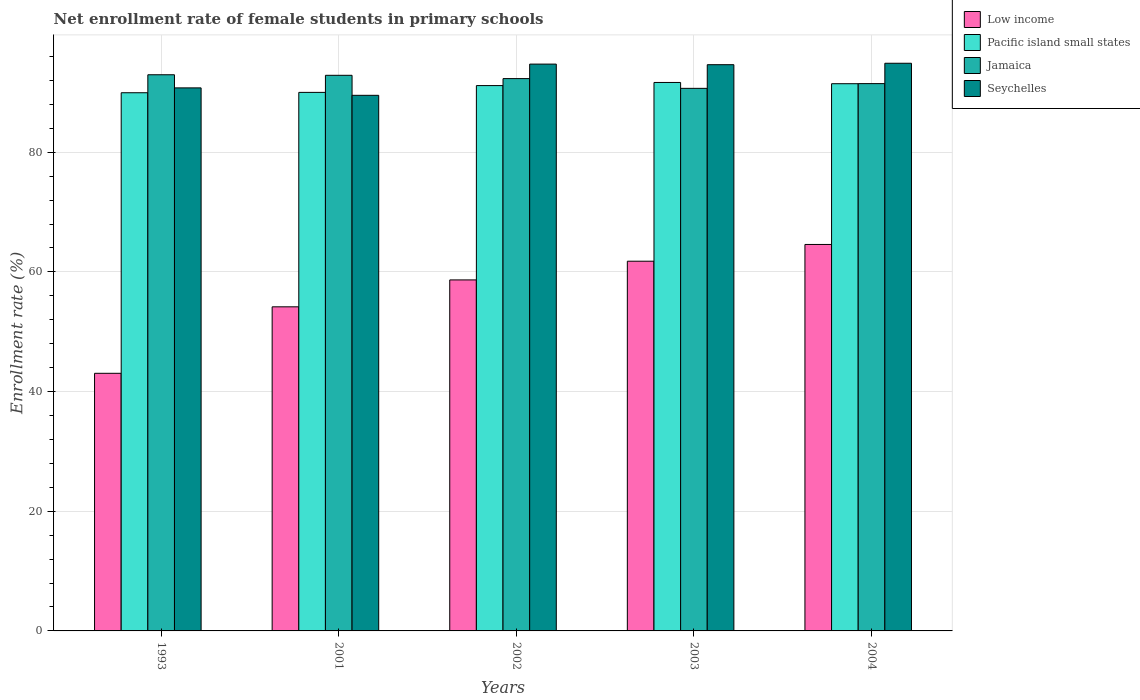How many different coloured bars are there?
Give a very brief answer. 4. How many groups of bars are there?
Your answer should be very brief. 5. Are the number of bars per tick equal to the number of legend labels?
Ensure brevity in your answer.  Yes. How many bars are there on the 4th tick from the left?
Make the answer very short. 4. How many bars are there on the 5th tick from the right?
Ensure brevity in your answer.  4. What is the label of the 2nd group of bars from the left?
Make the answer very short. 2001. In how many cases, is the number of bars for a given year not equal to the number of legend labels?
Keep it short and to the point. 0. What is the net enrollment rate of female students in primary schools in Jamaica in 1993?
Keep it short and to the point. 92.94. Across all years, what is the maximum net enrollment rate of female students in primary schools in Seychelles?
Ensure brevity in your answer.  94.86. Across all years, what is the minimum net enrollment rate of female students in primary schools in Pacific island small states?
Keep it short and to the point. 89.94. In which year was the net enrollment rate of female students in primary schools in Seychelles maximum?
Ensure brevity in your answer.  2004. What is the total net enrollment rate of female students in primary schools in Low income in the graph?
Keep it short and to the point. 282.24. What is the difference between the net enrollment rate of female students in primary schools in Pacific island small states in 1993 and that in 2002?
Provide a succinct answer. -1.2. What is the difference between the net enrollment rate of female students in primary schools in Seychelles in 2003 and the net enrollment rate of female students in primary schools in Jamaica in 2004?
Offer a very short reply. 3.16. What is the average net enrollment rate of female students in primary schools in Low income per year?
Give a very brief answer. 56.45. In the year 2002, what is the difference between the net enrollment rate of female students in primary schools in Low income and net enrollment rate of female students in primary schools in Jamaica?
Make the answer very short. -33.64. In how many years, is the net enrollment rate of female students in primary schools in Seychelles greater than 56 %?
Provide a short and direct response. 5. What is the ratio of the net enrollment rate of female students in primary schools in Pacific island small states in 2002 to that in 2004?
Offer a very short reply. 1. Is the net enrollment rate of female students in primary schools in Jamaica in 2001 less than that in 2004?
Make the answer very short. No. What is the difference between the highest and the second highest net enrollment rate of female students in primary schools in Pacific island small states?
Make the answer very short. 0.21. What is the difference between the highest and the lowest net enrollment rate of female students in primary schools in Jamaica?
Keep it short and to the point. 2.27. Is the sum of the net enrollment rate of female students in primary schools in Jamaica in 1993 and 2002 greater than the maximum net enrollment rate of female students in primary schools in Low income across all years?
Your answer should be very brief. Yes. What does the 4th bar from the left in 1993 represents?
Your response must be concise. Seychelles. What does the 2nd bar from the right in 1993 represents?
Your response must be concise. Jamaica. How many bars are there?
Provide a succinct answer. 20. Are all the bars in the graph horizontal?
Offer a terse response. No. Are the values on the major ticks of Y-axis written in scientific E-notation?
Your answer should be very brief. No. Does the graph contain any zero values?
Offer a terse response. No. How many legend labels are there?
Your answer should be very brief. 4. What is the title of the graph?
Provide a succinct answer. Net enrollment rate of female students in primary schools. Does "Aruba" appear as one of the legend labels in the graph?
Give a very brief answer. No. What is the label or title of the Y-axis?
Ensure brevity in your answer.  Enrollment rate (%). What is the Enrollment rate (%) of Low income in 1993?
Give a very brief answer. 43.05. What is the Enrollment rate (%) in Pacific island small states in 1993?
Ensure brevity in your answer.  89.94. What is the Enrollment rate (%) in Jamaica in 1993?
Provide a short and direct response. 92.94. What is the Enrollment rate (%) of Seychelles in 1993?
Keep it short and to the point. 90.75. What is the Enrollment rate (%) of Low income in 2001?
Keep it short and to the point. 54.16. What is the Enrollment rate (%) in Pacific island small states in 2001?
Provide a short and direct response. 90. What is the Enrollment rate (%) of Jamaica in 2001?
Offer a terse response. 92.85. What is the Enrollment rate (%) in Seychelles in 2001?
Make the answer very short. 89.51. What is the Enrollment rate (%) of Low income in 2002?
Keep it short and to the point. 58.66. What is the Enrollment rate (%) in Pacific island small states in 2002?
Make the answer very short. 91.13. What is the Enrollment rate (%) in Jamaica in 2002?
Give a very brief answer. 92.3. What is the Enrollment rate (%) of Seychelles in 2002?
Your response must be concise. 94.72. What is the Enrollment rate (%) of Low income in 2003?
Give a very brief answer. 61.78. What is the Enrollment rate (%) in Pacific island small states in 2003?
Offer a terse response. 91.65. What is the Enrollment rate (%) of Jamaica in 2003?
Make the answer very short. 90.67. What is the Enrollment rate (%) in Seychelles in 2003?
Your answer should be compact. 94.62. What is the Enrollment rate (%) in Low income in 2004?
Provide a succinct answer. 64.58. What is the Enrollment rate (%) in Pacific island small states in 2004?
Make the answer very short. 91.45. What is the Enrollment rate (%) in Jamaica in 2004?
Provide a short and direct response. 91.46. What is the Enrollment rate (%) of Seychelles in 2004?
Provide a succinct answer. 94.86. Across all years, what is the maximum Enrollment rate (%) in Low income?
Offer a very short reply. 64.58. Across all years, what is the maximum Enrollment rate (%) of Pacific island small states?
Provide a short and direct response. 91.65. Across all years, what is the maximum Enrollment rate (%) in Jamaica?
Give a very brief answer. 92.94. Across all years, what is the maximum Enrollment rate (%) in Seychelles?
Provide a short and direct response. 94.86. Across all years, what is the minimum Enrollment rate (%) of Low income?
Make the answer very short. 43.05. Across all years, what is the minimum Enrollment rate (%) in Pacific island small states?
Keep it short and to the point. 89.94. Across all years, what is the minimum Enrollment rate (%) of Jamaica?
Your answer should be very brief. 90.67. Across all years, what is the minimum Enrollment rate (%) in Seychelles?
Provide a short and direct response. 89.51. What is the total Enrollment rate (%) in Low income in the graph?
Provide a succinct answer. 282.24. What is the total Enrollment rate (%) of Pacific island small states in the graph?
Make the answer very short. 454.17. What is the total Enrollment rate (%) in Jamaica in the graph?
Make the answer very short. 460.23. What is the total Enrollment rate (%) of Seychelles in the graph?
Make the answer very short. 464.47. What is the difference between the Enrollment rate (%) of Low income in 1993 and that in 2001?
Keep it short and to the point. -11.11. What is the difference between the Enrollment rate (%) in Pacific island small states in 1993 and that in 2001?
Your response must be concise. -0.06. What is the difference between the Enrollment rate (%) in Jamaica in 1993 and that in 2001?
Ensure brevity in your answer.  0.09. What is the difference between the Enrollment rate (%) of Seychelles in 1993 and that in 2001?
Keep it short and to the point. 1.24. What is the difference between the Enrollment rate (%) of Low income in 1993 and that in 2002?
Give a very brief answer. -15.61. What is the difference between the Enrollment rate (%) of Pacific island small states in 1993 and that in 2002?
Your response must be concise. -1.2. What is the difference between the Enrollment rate (%) of Jamaica in 1993 and that in 2002?
Offer a terse response. 0.64. What is the difference between the Enrollment rate (%) of Seychelles in 1993 and that in 2002?
Your answer should be compact. -3.97. What is the difference between the Enrollment rate (%) of Low income in 1993 and that in 2003?
Ensure brevity in your answer.  -18.73. What is the difference between the Enrollment rate (%) in Pacific island small states in 1993 and that in 2003?
Provide a short and direct response. -1.72. What is the difference between the Enrollment rate (%) of Jamaica in 1993 and that in 2003?
Provide a short and direct response. 2.27. What is the difference between the Enrollment rate (%) in Seychelles in 1993 and that in 2003?
Your answer should be compact. -3.88. What is the difference between the Enrollment rate (%) of Low income in 1993 and that in 2004?
Provide a succinct answer. -21.53. What is the difference between the Enrollment rate (%) in Pacific island small states in 1993 and that in 2004?
Your answer should be very brief. -1.51. What is the difference between the Enrollment rate (%) in Jamaica in 1993 and that in 2004?
Provide a succinct answer. 1.48. What is the difference between the Enrollment rate (%) in Seychelles in 1993 and that in 2004?
Ensure brevity in your answer.  -4.12. What is the difference between the Enrollment rate (%) of Low income in 2001 and that in 2002?
Make the answer very short. -4.5. What is the difference between the Enrollment rate (%) in Pacific island small states in 2001 and that in 2002?
Keep it short and to the point. -1.14. What is the difference between the Enrollment rate (%) in Jamaica in 2001 and that in 2002?
Your answer should be very brief. 0.55. What is the difference between the Enrollment rate (%) of Seychelles in 2001 and that in 2002?
Offer a very short reply. -5.22. What is the difference between the Enrollment rate (%) in Low income in 2001 and that in 2003?
Provide a succinct answer. -7.62. What is the difference between the Enrollment rate (%) in Pacific island small states in 2001 and that in 2003?
Your answer should be very brief. -1.66. What is the difference between the Enrollment rate (%) of Jamaica in 2001 and that in 2003?
Your answer should be very brief. 2.18. What is the difference between the Enrollment rate (%) in Seychelles in 2001 and that in 2003?
Offer a very short reply. -5.12. What is the difference between the Enrollment rate (%) of Low income in 2001 and that in 2004?
Your answer should be compact. -10.42. What is the difference between the Enrollment rate (%) of Pacific island small states in 2001 and that in 2004?
Your answer should be compact. -1.45. What is the difference between the Enrollment rate (%) of Jamaica in 2001 and that in 2004?
Make the answer very short. 1.39. What is the difference between the Enrollment rate (%) of Seychelles in 2001 and that in 2004?
Provide a succinct answer. -5.36. What is the difference between the Enrollment rate (%) of Low income in 2002 and that in 2003?
Offer a very short reply. -3.12. What is the difference between the Enrollment rate (%) of Pacific island small states in 2002 and that in 2003?
Your answer should be very brief. -0.52. What is the difference between the Enrollment rate (%) of Jamaica in 2002 and that in 2003?
Your response must be concise. 1.63. What is the difference between the Enrollment rate (%) of Seychelles in 2002 and that in 2003?
Provide a short and direct response. 0.1. What is the difference between the Enrollment rate (%) of Low income in 2002 and that in 2004?
Your answer should be compact. -5.93. What is the difference between the Enrollment rate (%) of Pacific island small states in 2002 and that in 2004?
Your answer should be very brief. -0.31. What is the difference between the Enrollment rate (%) in Jamaica in 2002 and that in 2004?
Provide a short and direct response. 0.84. What is the difference between the Enrollment rate (%) in Seychelles in 2002 and that in 2004?
Keep it short and to the point. -0.14. What is the difference between the Enrollment rate (%) of Low income in 2003 and that in 2004?
Provide a short and direct response. -2.8. What is the difference between the Enrollment rate (%) in Pacific island small states in 2003 and that in 2004?
Keep it short and to the point. 0.21. What is the difference between the Enrollment rate (%) of Jamaica in 2003 and that in 2004?
Your answer should be very brief. -0.79. What is the difference between the Enrollment rate (%) in Seychelles in 2003 and that in 2004?
Offer a terse response. -0.24. What is the difference between the Enrollment rate (%) in Low income in 1993 and the Enrollment rate (%) in Pacific island small states in 2001?
Give a very brief answer. -46.95. What is the difference between the Enrollment rate (%) in Low income in 1993 and the Enrollment rate (%) in Jamaica in 2001?
Your answer should be compact. -49.8. What is the difference between the Enrollment rate (%) in Low income in 1993 and the Enrollment rate (%) in Seychelles in 2001?
Give a very brief answer. -46.46. What is the difference between the Enrollment rate (%) of Pacific island small states in 1993 and the Enrollment rate (%) of Jamaica in 2001?
Provide a succinct answer. -2.91. What is the difference between the Enrollment rate (%) of Pacific island small states in 1993 and the Enrollment rate (%) of Seychelles in 2001?
Provide a succinct answer. 0.43. What is the difference between the Enrollment rate (%) of Jamaica in 1993 and the Enrollment rate (%) of Seychelles in 2001?
Offer a very short reply. 3.44. What is the difference between the Enrollment rate (%) in Low income in 1993 and the Enrollment rate (%) in Pacific island small states in 2002?
Ensure brevity in your answer.  -48.08. What is the difference between the Enrollment rate (%) of Low income in 1993 and the Enrollment rate (%) of Jamaica in 2002?
Your response must be concise. -49.25. What is the difference between the Enrollment rate (%) of Low income in 1993 and the Enrollment rate (%) of Seychelles in 2002?
Your answer should be very brief. -51.67. What is the difference between the Enrollment rate (%) of Pacific island small states in 1993 and the Enrollment rate (%) of Jamaica in 2002?
Provide a short and direct response. -2.36. What is the difference between the Enrollment rate (%) in Pacific island small states in 1993 and the Enrollment rate (%) in Seychelles in 2002?
Offer a very short reply. -4.79. What is the difference between the Enrollment rate (%) in Jamaica in 1993 and the Enrollment rate (%) in Seychelles in 2002?
Give a very brief answer. -1.78. What is the difference between the Enrollment rate (%) in Low income in 1993 and the Enrollment rate (%) in Pacific island small states in 2003?
Give a very brief answer. -48.6. What is the difference between the Enrollment rate (%) of Low income in 1993 and the Enrollment rate (%) of Jamaica in 2003?
Ensure brevity in your answer.  -47.62. What is the difference between the Enrollment rate (%) of Low income in 1993 and the Enrollment rate (%) of Seychelles in 2003?
Ensure brevity in your answer.  -51.57. What is the difference between the Enrollment rate (%) of Pacific island small states in 1993 and the Enrollment rate (%) of Jamaica in 2003?
Your response must be concise. -0.73. What is the difference between the Enrollment rate (%) of Pacific island small states in 1993 and the Enrollment rate (%) of Seychelles in 2003?
Offer a terse response. -4.69. What is the difference between the Enrollment rate (%) in Jamaica in 1993 and the Enrollment rate (%) in Seychelles in 2003?
Offer a terse response. -1.68. What is the difference between the Enrollment rate (%) in Low income in 1993 and the Enrollment rate (%) in Pacific island small states in 2004?
Your response must be concise. -48.4. What is the difference between the Enrollment rate (%) in Low income in 1993 and the Enrollment rate (%) in Jamaica in 2004?
Your answer should be compact. -48.41. What is the difference between the Enrollment rate (%) of Low income in 1993 and the Enrollment rate (%) of Seychelles in 2004?
Make the answer very short. -51.81. What is the difference between the Enrollment rate (%) in Pacific island small states in 1993 and the Enrollment rate (%) in Jamaica in 2004?
Provide a succinct answer. -1.53. What is the difference between the Enrollment rate (%) of Pacific island small states in 1993 and the Enrollment rate (%) of Seychelles in 2004?
Keep it short and to the point. -4.93. What is the difference between the Enrollment rate (%) in Jamaica in 1993 and the Enrollment rate (%) in Seychelles in 2004?
Keep it short and to the point. -1.92. What is the difference between the Enrollment rate (%) in Low income in 2001 and the Enrollment rate (%) in Pacific island small states in 2002?
Provide a succinct answer. -36.97. What is the difference between the Enrollment rate (%) of Low income in 2001 and the Enrollment rate (%) of Jamaica in 2002?
Keep it short and to the point. -38.14. What is the difference between the Enrollment rate (%) in Low income in 2001 and the Enrollment rate (%) in Seychelles in 2002?
Your answer should be compact. -40.56. What is the difference between the Enrollment rate (%) of Pacific island small states in 2001 and the Enrollment rate (%) of Jamaica in 2002?
Make the answer very short. -2.3. What is the difference between the Enrollment rate (%) in Pacific island small states in 2001 and the Enrollment rate (%) in Seychelles in 2002?
Provide a short and direct response. -4.72. What is the difference between the Enrollment rate (%) in Jamaica in 2001 and the Enrollment rate (%) in Seychelles in 2002?
Your response must be concise. -1.87. What is the difference between the Enrollment rate (%) in Low income in 2001 and the Enrollment rate (%) in Pacific island small states in 2003?
Keep it short and to the point. -37.49. What is the difference between the Enrollment rate (%) of Low income in 2001 and the Enrollment rate (%) of Jamaica in 2003?
Your answer should be very brief. -36.51. What is the difference between the Enrollment rate (%) of Low income in 2001 and the Enrollment rate (%) of Seychelles in 2003?
Your response must be concise. -40.46. What is the difference between the Enrollment rate (%) of Pacific island small states in 2001 and the Enrollment rate (%) of Jamaica in 2003?
Ensure brevity in your answer.  -0.67. What is the difference between the Enrollment rate (%) in Pacific island small states in 2001 and the Enrollment rate (%) in Seychelles in 2003?
Provide a succinct answer. -4.63. What is the difference between the Enrollment rate (%) of Jamaica in 2001 and the Enrollment rate (%) of Seychelles in 2003?
Keep it short and to the point. -1.77. What is the difference between the Enrollment rate (%) in Low income in 2001 and the Enrollment rate (%) in Pacific island small states in 2004?
Provide a short and direct response. -37.29. What is the difference between the Enrollment rate (%) of Low income in 2001 and the Enrollment rate (%) of Jamaica in 2004?
Provide a succinct answer. -37.3. What is the difference between the Enrollment rate (%) in Low income in 2001 and the Enrollment rate (%) in Seychelles in 2004?
Offer a very short reply. -40.7. What is the difference between the Enrollment rate (%) in Pacific island small states in 2001 and the Enrollment rate (%) in Jamaica in 2004?
Your answer should be very brief. -1.46. What is the difference between the Enrollment rate (%) in Pacific island small states in 2001 and the Enrollment rate (%) in Seychelles in 2004?
Offer a terse response. -4.87. What is the difference between the Enrollment rate (%) in Jamaica in 2001 and the Enrollment rate (%) in Seychelles in 2004?
Make the answer very short. -2.01. What is the difference between the Enrollment rate (%) in Low income in 2002 and the Enrollment rate (%) in Pacific island small states in 2003?
Make the answer very short. -33. What is the difference between the Enrollment rate (%) of Low income in 2002 and the Enrollment rate (%) of Jamaica in 2003?
Your response must be concise. -32.01. What is the difference between the Enrollment rate (%) of Low income in 2002 and the Enrollment rate (%) of Seychelles in 2003?
Provide a succinct answer. -35.97. What is the difference between the Enrollment rate (%) in Pacific island small states in 2002 and the Enrollment rate (%) in Jamaica in 2003?
Provide a short and direct response. 0.46. What is the difference between the Enrollment rate (%) of Pacific island small states in 2002 and the Enrollment rate (%) of Seychelles in 2003?
Offer a very short reply. -3.49. What is the difference between the Enrollment rate (%) in Jamaica in 2002 and the Enrollment rate (%) in Seychelles in 2003?
Keep it short and to the point. -2.33. What is the difference between the Enrollment rate (%) in Low income in 2002 and the Enrollment rate (%) in Pacific island small states in 2004?
Ensure brevity in your answer.  -32.79. What is the difference between the Enrollment rate (%) in Low income in 2002 and the Enrollment rate (%) in Jamaica in 2004?
Provide a succinct answer. -32.8. What is the difference between the Enrollment rate (%) in Low income in 2002 and the Enrollment rate (%) in Seychelles in 2004?
Ensure brevity in your answer.  -36.21. What is the difference between the Enrollment rate (%) in Pacific island small states in 2002 and the Enrollment rate (%) in Jamaica in 2004?
Make the answer very short. -0.33. What is the difference between the Enrollment rate (%) of Pacific island small states in 2002 and the Enrollment rate (%) of Seychelles in 2004?
Give a very brief answer. -3.73. What is the difference between the Enrollment rate (%) in Jamaica in 2002 and the Enrollment rate (%) in Seychelles in 2004?
Provide a succinct answer. -2.56. What is the difference between the Enrollment rate (%) in Low income in 2003 and the Enrollment rate (%) in Pacific island small states in 2004?
Your response must be concise. -29.66. What is the difference between the Enrollment rate (%) of Low income in 2003 and the Enrollment rate (%) of Jamaica in 2004?
Your response must be concise. -29.68. What is the difference between the Enrollment rate (%) of Low income in 2003 and the Enrollment rate (%) of Seychelles in 2004?
Provide a succinct answer. -33.08. What is the difference between the Enrollment rate (%) of Pacific island small states in 2003 and the Enrollment rate (%) of Jamaica in 2004?
Offer a very short reply. 0.19. What is the difference between the Enrollment rate (%) of Pacific island small states in 2003 and the Enrollment rate (%) of Seychelles in 2004?
Your answer should be very brief. -3.21. What is the difference between the Enrollment rate (%) of Jamaica in 2003 and the Enrollment rate (%) of Seychelles in 2004?
Offer a terse response. -4.19. What is the average Enrollment rate (%) in Low income per year?
Offer a terse response. 56.45. What is the average Enrollment rate (%) of Pacific island small states per year?
Offer a terse response. 90.83. What is the average Enrollment rate (%) of Jamaica per year?
Provide a succinct answer. 92.05. What is the average Enrollment rate (%) of Seychelles per year?
Your response must be concise. 92.89. In the year 1993, what is the difference between the Enrollment rate (%) in Low income and Enrollment rate (%) in Pacific island small states?
Offer a very short reply. -46.89. In the year 1993, what is the difference between the Enrollment rate (%) of Low income and Enrollment rate (%) of Jamaica?
Your answer should be compact. -49.89. In the year 1993, what is the difference between the Enrollment rate (%) of Low income and Enrollment rate (%) of Seychelles?
Your answer should be compact. -47.7. In the year 1993, what is the difference between the Enrollment rate (%) of Pacific island small states and Enrollment rate (%) of Jamaica?
Make the answer very short. -3. In the year 1993, what is the difference between the Enrollment rate (%) of Pacific island small states and Enrollment rate (%) of Seychelles?
Your answer should be very brief. -0.81. In the year 1993, what is the difference between the Enrollment rate (%) in Jamaica and Enrollment rate (%) in Seychelles?
Make the answer very short. 2.19. In the year 2001, what is the difference between the Enrollment rate (%) in Low income and Enrollment rate (%) in Pacific island small states?
Your response must be concise. -35.84. In the year 2001, what is the difference between the Enrollment rate (%) of Low income and Enrollment rate (%) of Jamaica?
Offer a terse response. -38.69. In the year 2001, what is the difference between the Enrollment rate (%) in Low income and Enrollment rate (%) in Seychelles?
Your answer should be compact. -35.34. In the year 2001, what is the difference between the Enrollment rate (%) in Pacific island small states and Enrollment rate (%) in Jamaica?
Offer a terse response. -2.85. In the year 2001, what is the difference between the Enrollment rate (%) of Pacific island small states and Enrollment rate (%) of Seychelles?
Your answer should be compact. 0.49. In the year 2001, what is the difference between the Enrollment rate (%) of Jamaica and Enrollment rate (%) of Seychelles?
Ensure brevity in your answer.  3.34. In the year 2002, what is the difference between the Enrollment rate (%) in Low income and Enrollment rate (%) in Pacific island small states?
Ensure brevity in your answer.  -32.47. In the year 2002, what is the difference between the Enrollment rate (%) in Low income and Enrollment rate (%) in Jamaica?
Your response must be concise. -33.64. In the year 2002, what is the difference between the Enrollment rate (%) in Low income and Enrollment rate (%) in Seychelles?
Offer a terse response. -36.06. In the year 2002, what is the difference between the Enrollment rate (%) in Pacific island small states and Enrollment rate (%) in Jamaica?
Your answer should be compact. -1.17. In the year 2002, what is the difference between the Enrollment rate (%) of Pacific island small states and Enrollment rate (%) of Seychelles?
Make the answer very short. -3.59. In the year 2002, what is the difference between the Enrollment rate (%) of Jamaica and Enrollment rate (%) of Seychelles?
Give a very brief answer. -2.42. In the year 2003, what is the difference between the Enrollment rate (%) in Low income and Enrollment rate (%) in Pacific island small states?
Make the answer very short. -29.87. In the year 2003, what is the difference between the Enrollment rate (%) in Low income and Enrollment rate (%) in Jamaica?
Ensure brevity in your answer.  -28.89. In the year 2003, what is the difference between the Enrollment rate (%) in Low income and Enrollment rate (%) in Seychelles?
Your answer should be very brief. -32.84. In the year 2003, what is the difference between the Enrollment rate (%) in Pacific island small states and Enrollment rate (%) in Jamaica?
Your answer should be compact. 0.98. In the year 2003, what is the difference between the Enrollment rate (%) of Pacific island small states and Enrollment rate (%) of Seychelles?
Give a very brief answer. -2.97. In the year 2003, what is the difference between the Enrollment rate (%) in Jamaica and Enrollment rate (%) in Seychelles?
Keep it short and to the point. -3.95. In the year 2004, what is the difference between the Enrollment rate (%) in Low income and Enrollment rate (%) in Pacific island small states?
Your response must be concise. -26.86. In the year 2004, what is the difference between the Enrollment rate (%) in Low income and Enrollment rate (%) in Jamaica?
Give a very brief answer. -26.88. In the year 2004, what is the difference between the Enrollment rate (%) of Low income and Enrollment rate (%) of Seychelles?
Provide a short and direct response. -30.28. In the year 2004, what is the difference between the Enrollment rate (%) in Pacific island small states and Enrollment rate (%) in Jamaica?
Ensure brevity in your answer.  -0.02. In the year 2004, what is the difference between the Enrollment rate (%) in Pacific island small states and Enrollment rate (%) in Seychelles?
Keep it short and to the point. -3.42. In the year 2004, what is the difference between the Enrollment rate (%) of Jamaica and Enrollment rate (%) of Seychelles?
Provide a short and direct response. -3.4. What is the ratio of the Enrollment rate (%) in Low income in 1993 to that in 2001?
Provide a short and direct response. 0.79. What is the ratio of the Enrollment rate (%) of Pacific island small states in 1993 to that in 2001?
Ensure brevity in your answer.  1. What is the ratio of the Enrollment rate (%) in Jamaica in 1993 to that in 2001?
Make the answer very short. 1. What is the ratio of the Enrollment rate (%) in Seychelles in 1993 to that in 2001?
Ensure brevity in your answer.  1.01. What is the ratio of the Enrollment rate (%) in Low income in 1993 to that in 2002?
Your response must be concise. 0.73. What is the ratio of the Enrollment rate (%) in Pacific island small states in 1993 to that in 2002?
Ensure brevity in your answer.  0.99. What is the ratio of the Enrollment rate (%) in Seychelles in 1993 to that in 2002?
Provide a short and direct response. 0.96. What is the ratio of the Enrollment rate (%) in Low income in 1993 to that in 2003?
Provide a succinct answer. 0.7. What is the ratio of the Enrollment rate (%) of Pacific island small states in 1993 to that in 2003?
Offer a very short reply. 0.98. What is the ratio of the Enrollment rate (%) in Jamaica in 1993 to that in 2003?
Your answer should be compact. 1.02. What is the ratio of the Enrollment rate (%) of Seychelles in 1993 to that in 2003?
Provide a succinct answer. 0.96. What is the ratio of the Enrollment rate (%) in Low income in 1993 to that in 2004?
Offer a terse response. 0.67. What is the ratio of the Enrollment rate (%) in Pacific island small states in 1993 to that in 2004?
Offer a very short reply. 0.98. What is the ratio of the Enrollment rate (%) of Jamaica in 1993 to that in 2004?
Give a very brief answer. 1.02. What is the ratio of the Enrollment rate (%) of Seychelles in 1993 to that in 2004?
Make the answer very short. 0.96. What is the ratio of the Enrollment rate (%) of Low income in 2001 to that in 2002?
Your response must be concise. 0.92. What is the ratio of the Enrollment rate (%) in Pacific island small states in 2001 to that in 2002?
Provide a short and direct response. 0.99. What is the ratio of the Enrollment rate (%) in Jamaica in 2001 to that in 2002?
Offer a very short reply. 1.01. What is the ratio of the Enrollment rate (%) in Seychelles in 2001 to that in 2002?
Your answer should be compact. 0.94. What is the ratio of the Enrollment rate (%) in Low income in 2001 to that in 2003?
Offer a very short reply. 0.88. What is the ratio of the Enrollment rate (%) in Pacific island small states in 2001 to that in 2003?
Provide a succinct answer. 0.98. What is the ratio of the Enrollment rate (%) in Jamaica in 2001 to that in 2003?
Provide a short and direct response. 1.02. What is the ratio of the Enrollment rate (%) of Seychelles in 2001 to that in 2003?
Offer a very short reply. 0.95. What is the ratio of the Enrollment rate (%) in Low income in 2001 to that in 2004?
Your answer should be compact. 0.84. What is the ratio of the Enrollment rate (%) of Pacific island small states in 2001 to that in 2004?
Provide a short and direct response. 0.98. What is the ratio of the Enrollment rate (%) of Jamaica in 2001 to that in 2004?
Ensure brevity in your answer.  1.02. What is the ratio of the Enrollment rate (%) in Seychelles in 2001 to that in 2004?
Offer a very short reply. 0.94. What is the ratio of the Enrollment rate (%) of Low income in 2002 to that in 2003?
Offer a very short reply. 0.95. What is the ratio of the Enrollment rate (%) in Pacific island small states in 2002 to that in 2003?
Offer a very short reply. 0.99. What is the ratio of the Enrollment rate (%) of Jamaica in 2002 to that in 2003?
Your response must be concise. 1.02. What is the ratio of the Enrollment rate (%) of Seychelles in 2002 to that in 2003?
Provide a short and direct response. 1. What is the ratio of the Enrollment rate (%) of Low income in 2002 to that in 2004?
Provide a succinct answer. 0.91. What is the ratio of the Enrollment rate (%) in Jamaica in 2002 to that in 2004?
Provide a succinct answer. 1.01. What is the ratio of the Enrollment rate (%) in Seychelles in 2002 to that in 2004?
Your answer should be compact. 1. What is the ratio of the Enrollment rate (%) in Low income in 2003 to that in 2004?
Provide a succinct answer. 0.96. What is the ratio of the Enrollment rate (%) in Jamaica in 2003 to that in 2004?
Provide a succinct answer. 0.99. What is the difference between the highest and the second highest Enrollment rate (%) of Low income?
Your answer should be very brief. 2.8. What is the difference between the highest and the second highest Enrollment rate (%) of Pacific island small states?
Offer a terse response. 0.21. What is the difference between the highest and the second highest Enrollment rate (%) of Jamaica?
Provide a short and direct response. 0.09. What is the difference between the highest and the second highest Enrollment rate (%) in Seychelles?
Give a very brief answer. 0.14. What is the difference between the highest and the lowest Enrollment rate (%) in Low income?
Offer a very short reply. 21.53. What is the difference between the highest and the lowest Enrollment rate (%) of Pacific island small states?
Your answer should be very brief. 1.72. What is the difference between the highest and the lowest Enrollment rate (%) in Jamaica?
Provide a short and direct response. 2.27. What is the difference between the highest and the lowest Enrollment rate (%) of Seychelles?
Ensure brevity in your answer.  5.36. 